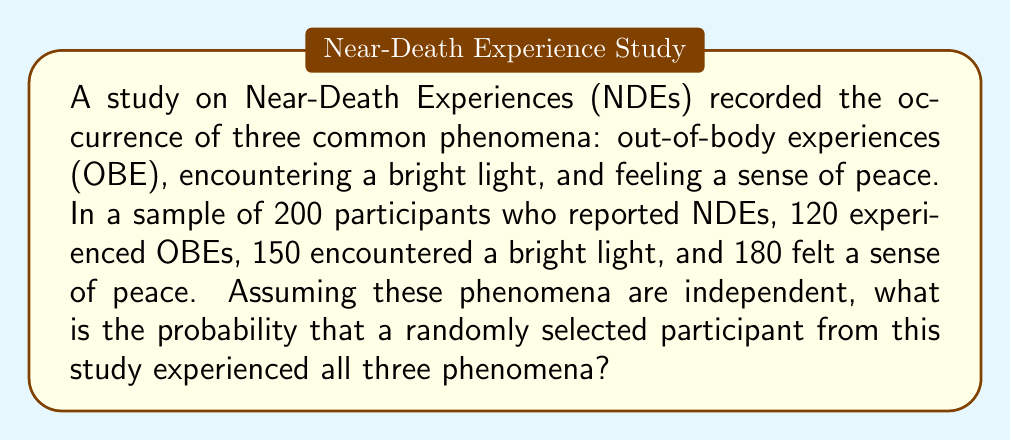Can you answer this question? To solve this problem, we'll use the concept of independent events and probability multiplication.

1. First, let's calculate the probability of each phenomenon occurring:

   P(OBE) = $\frac{120}{200} = 0.6$
   P(Bright Light) = $\frac{150}{200} = 0.75$
   P(Sense of Peace) = $\frac{180}{200} = 0.9$

2. Since we're assuming these phenomena are independent, we can multiply their individual probabilities to find the probability of all three occurring together:

   $$P(\text{All three}) = P(\text{OBE}) \times P(\text{Bright Light}) \times P(\text{Sense of Peace})$$

3. Substituting the values:

   $$P(\text{All three}) = 0.6 \times 0.75 \times 0.9$$

4. Calculating the result:

   $$P(\text{All three}) = 0.405$$

5. To express this as a percentage:

   $$0.405 \times 100\% = 40.5\%$$

Therefore, the probability that a randomly selected participant experienced all three phenomena is 0.405 or 40.5%.
Answer: 0.405 or 40.5% 